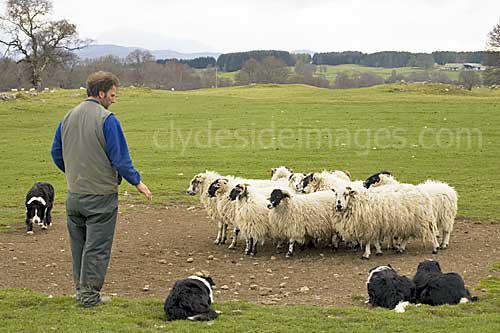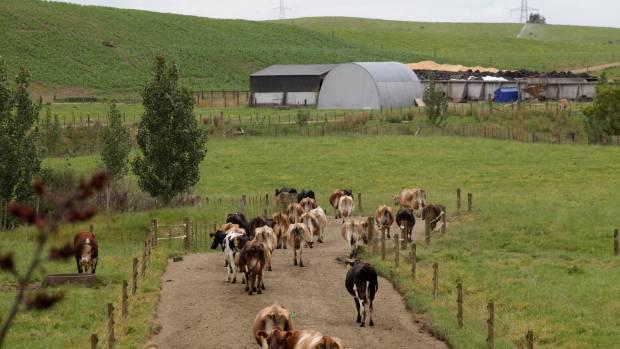The first image is the image on the left, the second image is the image on the right. For the images shown, is this caption "In one image, a man is standing in a green, grassy area with multiple dogs and multiple sheep." true? Answer yes or no. Yes. The first image is the image on the left, the second image is the image on the right. Analyze the images presented: Is the assertion "An image includes a person with just one dog." valid? Answer yes or no. No. 